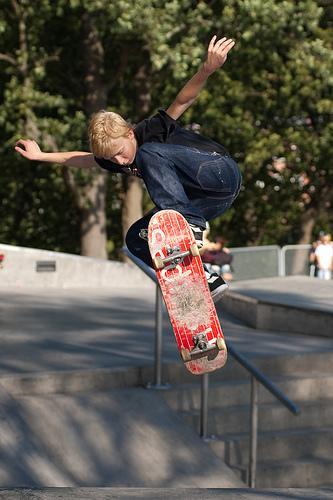For the multi-choice VQA task, choose the correct description of the skateboard wheels: A) black and large B) white and small C) green and round White and small For the referential expression grounding task, identify the main action happening in the image and the skateboarder's position relative to a ramp. The main action is the skateboarder jumping in mid-air, and the skateboarder is located above the skateboard ramp. Describe the location and environment where the skateboarding event is taking place. The event is taking place at a skate park with a concrete ramp, metal railings, and trees in the background. What type of footwear is the skateboarder wearing, and what color is it? The skateboarder is wearing a black and white skateboard shoe. What is the boy wearing and what is happening to him? The boy is wearing blue jeans and a black shirt, and he is in mid-air on a skateboard. Identify the color and condition of the skateboard in the image. The skateboard is red and appears to be scratched up. What can you infer about the people present in the image based on their clothing and physical appearance? There is a person wearing white, a boy with blonde hair, and a man wearing a dark short-sleeved shirt and dark blue jeans.  For the visual entailment task, determine whether the skateboarder is doing a jump or grinding on a rail. The skateboarder is doing a jump. In the product advertisement task, describe the skateboard's key features from the image. The skateboard features a vibrant red color with white polyurethane wheels, and a durable design for impressive tricks and jumps. What are some of the objects and structures surrounding the skateboarder in the image? There is a grey concrete skateboard ramp, metal hand rail, cement steps, and a concrete wall around the skateboarder. 